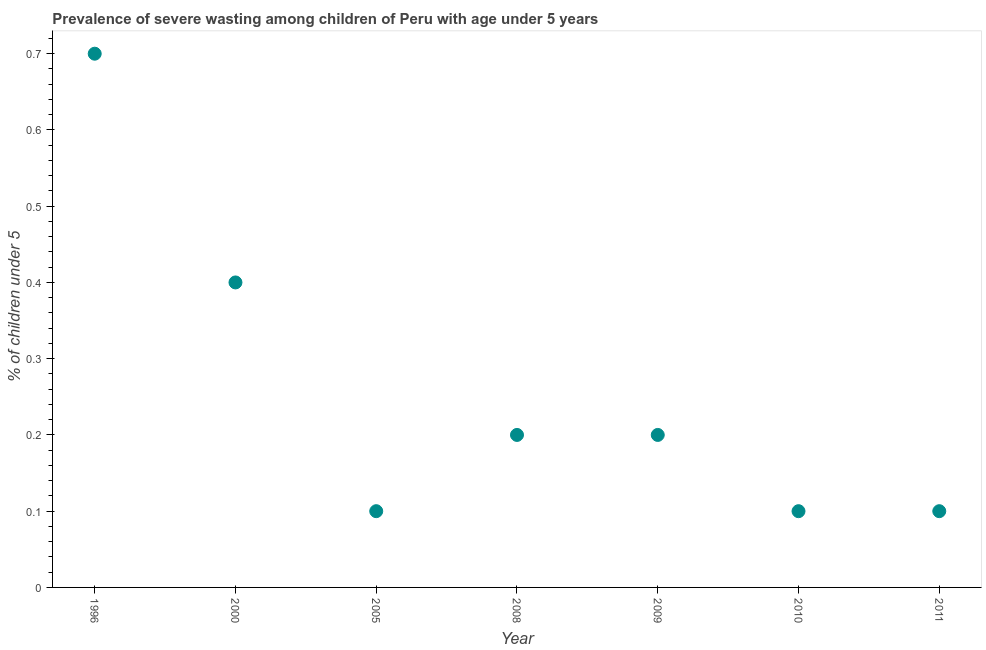What is the prevalence of severe wasting in 1996?
Your answer should be compact. 0.7. Across all years, what is the maximum prevalence of severe wasting?
Keep it short and to the point. 0.7. Across all years, what is the minimum prevalence of severe wasting?
Give a very brief answer. 0.1. In which year was the prevalence of severe wasting maximum?
Provide a succinct answer. 1996. In which year was the prevalence of severe wasting minimum?
Give a very brief answer. 2005. What is the sum of the prevalence of severe wasting?
Make the answer very short. 1.8. What is the difference between the prevalence of severe wasting in 2008 and 2009?
Provide a succinct answer. 0. What is the average prevalence of severe wasting per year?
Provide a short and direct response. 0.26. What is the median prevalence of severe wasting?
Your response must be concise. 0.2. In how many years, is the prevalence of severe wasting greater than 0.5 %?
Make the answer very short. 1. What is the ratio of the prevalence of severe wasting in 1996 to that in 2008?
Your answer should be very brief. 3.5. Is the prevalence of severe wasting in 2005 less than that in 2008?
Your answer should be compact. Yes. Is the difference between the prevalence of severe wasting in 2008 and 2009 greater than the difference between any two years?
Give a very brief answer. No. What is the difference between the highest and the second highest prevalence of severe wasting?
Make the answer very short. 0.3. What is the difference between the highest and the lowest prevalence of severe wasting?
Give a very brief answer. 0.6. Does the prevalence of severe wasting monotonically increase over the years?
Ensure brevity in your answer.  No. How many dotlines are there?
Give a very brief answer. 1. How many years are there in the graph?
Keep it short and to the point. 7. What is the difference between two consecutive major ticks on the Y-axis?
Keep it short and to the point. 0.1. Does the graph contain any zero values?
Offer a terse response. No. What is the title of the graph?
Give a very brief answer. Prevalence of severe wasting among children of Peru with age under 5 years. What is the label or title of the X-axis?
Your answer should be compact. Year. What is the label or title of the Y-axis?
Offer a very short reply.  % of children under 5. What is the  % of children under 5 in 1996?
Offer a very short reply. 0.7. What is the  % of children under 5 in 2000?
Ensure brevity in your answer.  0.4. What is the  % of children under 5 in 2005?
Your response must be concise. 0.1. What is the  % of children under 5 in 2008?
Make the answer very short. 0.2. What is the  % of children under 5 in 2009?
Offer a very short reply. 0.2. What is the  % of children under 5 in 2010?
Offer a terse response. 0.1. What is the  % of children under 5 in 2011?
Give a very brief answer. 0.1. What is the difference between the  % of children under 5 in 1996 and 2005?
Keep it short and to the point. 0.6. What is the difference between the  % of children under 5 in 1996 and 2009?
Make the answer very short. 0.5. What is the difference between the  % of children under 5 in 1996 and 2011?
Offer a very short reply. 0.6. What is the difference between the  % of children under 5 in 2000 and 2005?
Offer a very short reply. 0.3. What is the difference between the  % of children under 5 in 2000 and 2009?
Provide a succinct answer. 0.2. What is the difference between the  % of children under 5 in 2000 and 2011?
Ensure brevity in your answer.  0.3. What is the difference between the  % of children under 5 in 2005 and 2008?
Offer a terse response. -0.1. What is the difference between the  % of children under 5 in 2008 and 2010?
Your response must be concise. 0.1. What is the difference between the  % of children under 5 in 2008 and 2011?
Make the answer very short. 0.1. What is the ratio of the  % of children under 5 in 1996 to that in 2005?
Provide a succinct answer. 7. What is the ratio of the  % of children under 5 in 1996 to that in 2008?
Your answer should be compact. 3.5. What is the ratio of the  % of children under 5 in 1996 to that in 2010?
Keep it short and to the point. 7. What is the ratio of the  % of children under 5 in 2000 to that in 2005?
Provide a short and direct response. 4. What is the ratio of the  % of children under 5 in 2000 to that in 2011?
Provide a succinct answer. 4. What is the ratio of the  % of children under 5 in 2005 to that in 2010?
Give a very brief answer. 1. What is the ratio of the  % of children under 5 in 2005 to that in 2011?
Give a very brief answer. 1. What is the ratio of the  % of children under 5 in 2008 to that in 2009?
Keep it short and to the point. 1. What is the ratio of the  % of children under 5 in 2008 to that in 2011?
Provide a succinct answer. 2. What is the ratio of the  % of children under 5 in 2009 to that in 2011?
Offer a very short reply. 2. What is the ratio of the  % of children under 5 in 2010 to that in 2011?
Offer a very short reply. 1. 